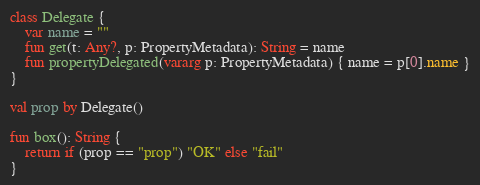<code> <loc_0><loc_0><loc_500><loc_500><_Kotlin_>class Delegate {
    var name = ""
    fun get(t: Any?, p: PropertyMetadata): String = name
    fun propertyDelegated(vararg p: PropertyMetadata) { name = p[0].name }
}

val prop by Delegate()

fun box(): String {
    return if (prop == "prop") "OK" else "fail"
}
</code> 